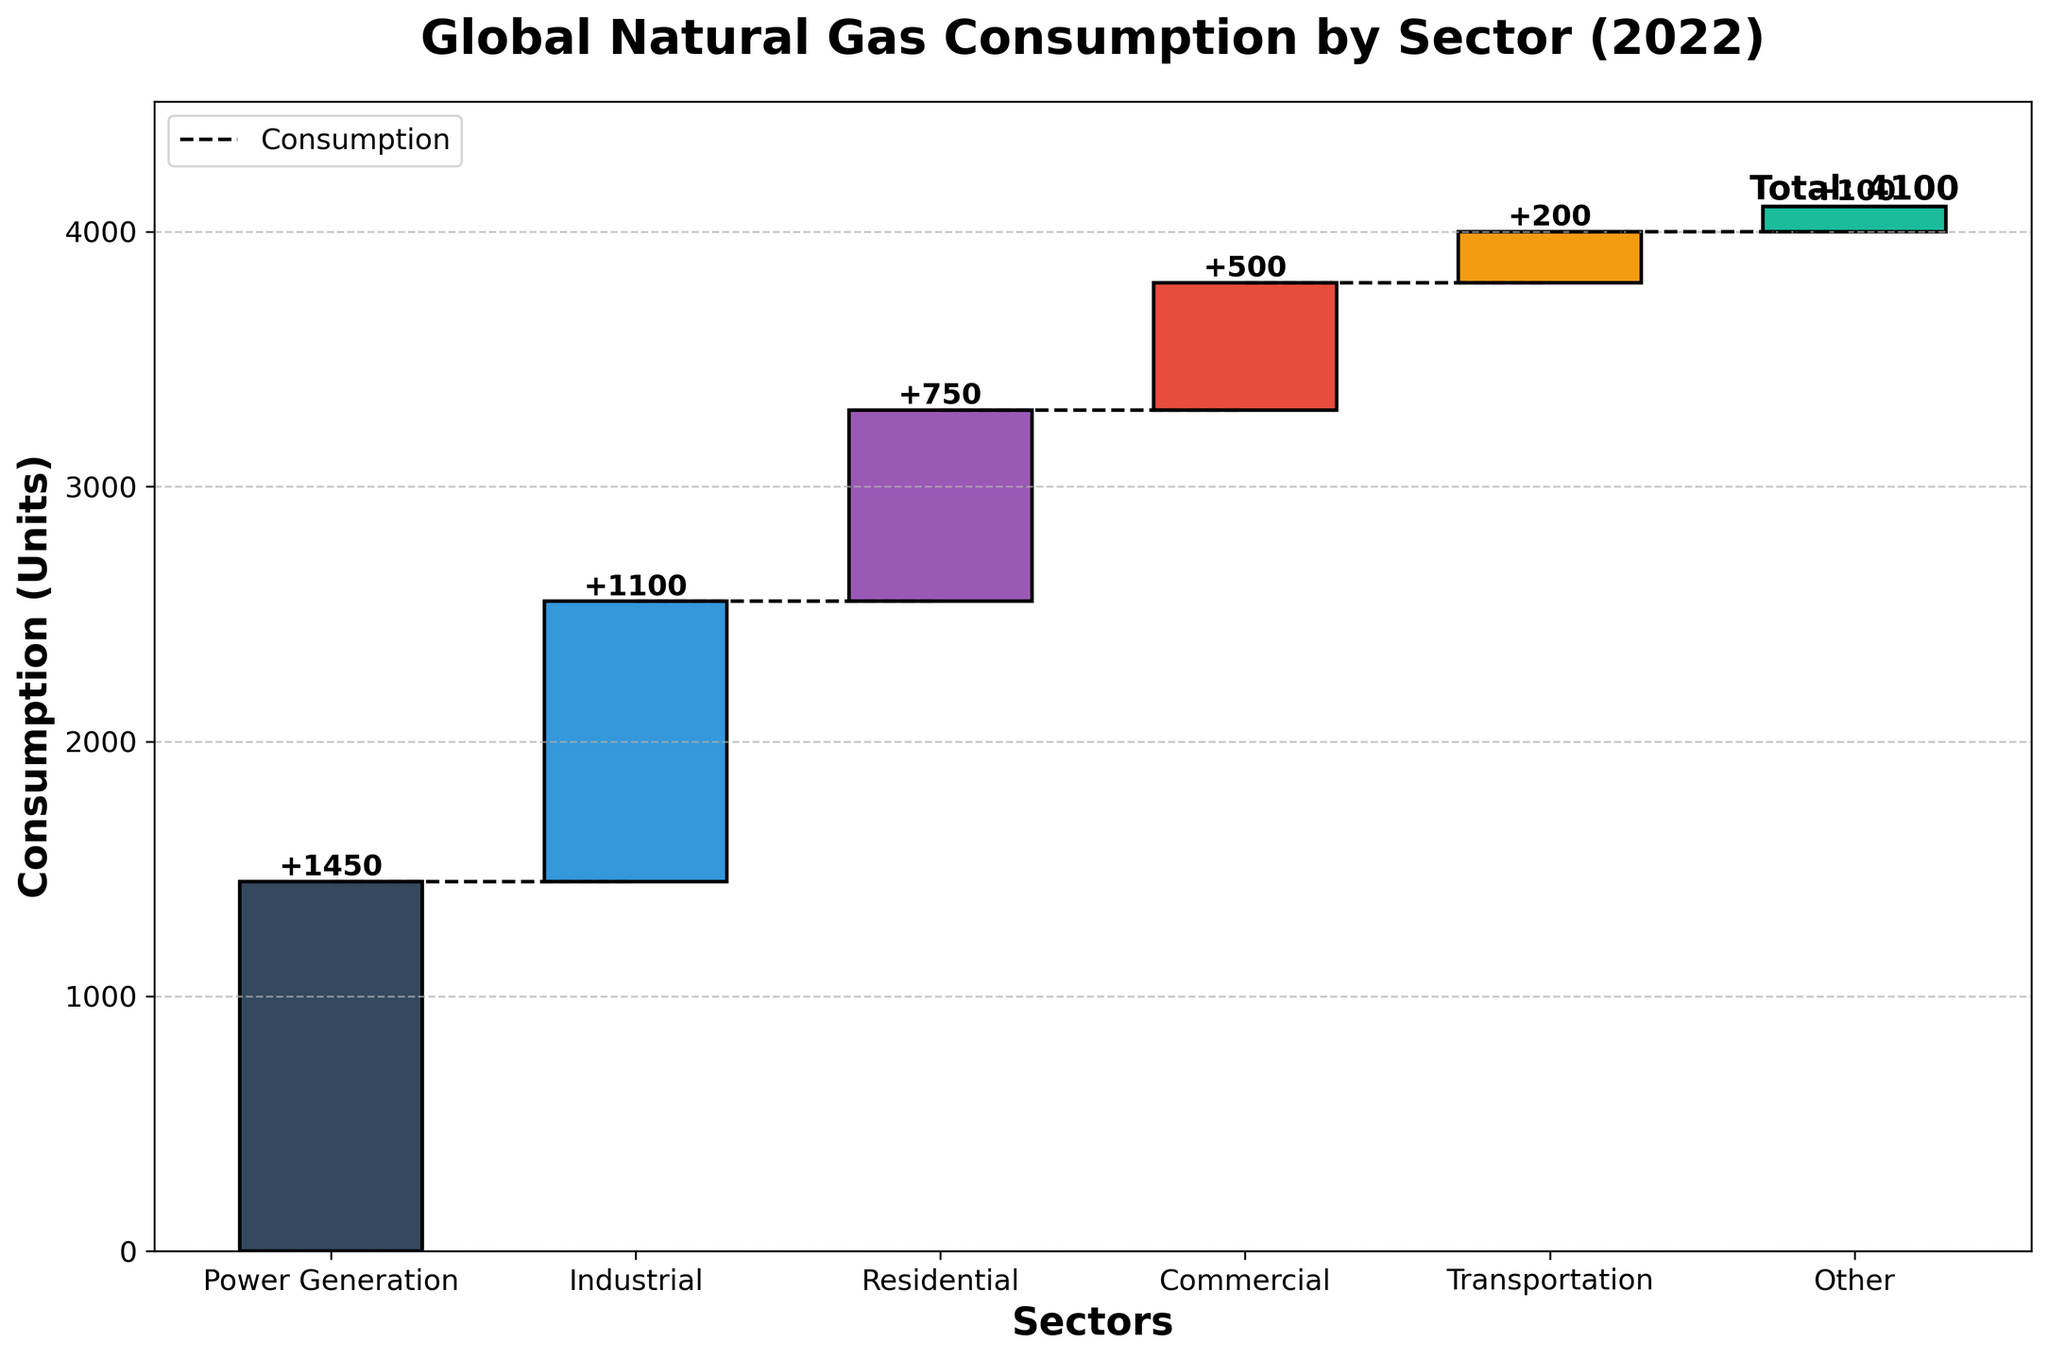What is the title of the chart? The title of the chart is located at the top center and provides a brief description of the data being visualized. In this case, it is "Global Natural Gas Consumption by Sector (2022)".
Answer: Global Natural Gas Consumption by Sector (2022) Which sector has the highest natural gas consumption in 2022? We need to look for the tallest bar in the chart to identify the sector with the highest consumption. The tallest bar is for the "Power Generation" sector.
Answer: Power Generation How much natural gas does the Industrial sector consume in 2022? The bar labeled "Industrial" shows the increment of natural gas consumption, marked as 1100 units directly above the bar.
Answer: 1100 units What is the total natural gas consumption across all sectors in 2022? The chart has a specific bar usually at the end that represents the total consumption. Here, it is labeled as "Total" with a value of 4100 units.
Answer: 4100 units Between which two sectors does the natural gas consumption increase the most? To determine this, we need to find the largest difference between two consecutive bars by observing the heights. The largest step-up occurs between "Industrial" (1100) and "Power Generation" (1450), which is an increase of 350 units.
Answer: From Industrial to Power Generation What is the combined natural gas consumption of the Residential and Commercial sectors? Add the values of the Residential sector (750) and the Commercial sector (500). The combined consumption is 750 + 500 = 1250 units.
Answer: 1250 units Which sector has the least amount of natural gas consumption in 2022? Look for the shortest bar in the chart, which indicates the minimum consumption. The "Other" sector has the least consumption at 100 units.
Answer: Other How does the transportation sector's consumption compare to the commercial sector? Compare the heights of the bars labeled "Transportation" and "Commercial". The "Transportation" sector (200 units) consumes less than the "Commercial" sector (500 units).
Answer: Less than What percentage of the total natural gas consumption does the Power Generation sector account for? First, we need to find the Power Generation consumption (1450 units) and the total consumption (4100 units). The percentage is calculated as (1450/4100) * 100. Hence, (1450 / 4100) * 100 ≈ 35.37%.
Answer: Approximately 35.37% By how much does the residential sector's consumption exceed that of the transportation sector? Subtract the transportation sector's consumption (200 units) from the residential sector's consumption (750 units). The difference is 750 - 200 = 550 units.
Answer: 550 units 